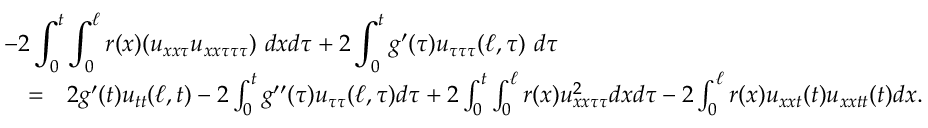Convert formula to latex. <formula><loc_0><loc_0><loc_500><loc_500>\begin{array} { r l r } { { - 2 \int _ { 0 } ^ { t } \int _ { 0 } ^ { \ell } r ( x ) ( u _ { x x \tau } u _ { x x \tau \tau \tau } ) \ d x d \tau + 2 \int _ { 0 } ^ { t } g ^ { \prime } ( \tau ) u _ { \tau \tau \tau } ( \ell , \tau ) \ d \tau } } \\ & { = } & { 2 g ^ { \prime } ( t ) u _ { t t } ( \ell , t ) - 2 \int _ { 0 } ^ { t } g ^ { \prime \prime } ( \tau ) u _ { \tau \tau } ( \ell , \tau ) d \tau + 2 \int _ { 0 } ^ { t } \int _ { 0 } ^ { \ell } r ( x ) u _ { x x \tau \tau } ^ { 2 } d x d \tau - 2 \int _ { 0 } ^ { \ell } r ( x ) u _ { x x t } ( t ) u _ { x x t t } ( t ) d x . } \end{array}</formula> 